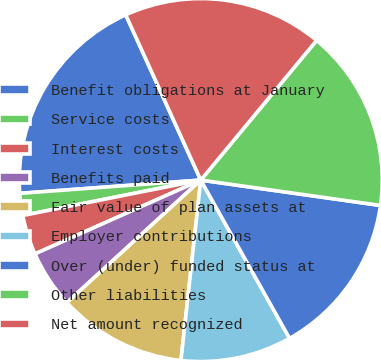<chart> <loc_0><loc_0><loc_500><loc_500><pie_chart><fcel>Benefit obligations at January<fcel>Service costs<fcel>Interest costs<fcel>Benefits paid<fcel>Fair value of plan assets at<fcel>Employer contributions<fcel>Over (under) funded status at<fcel>Other liabilities<fcel>Net amount recognized<nl><fcel>19.38%<fcel>1.96%<fcel>3.54%<fcel>5.13%<fcel>11.46%<fcel>9.88%<fcel>14.63%<fcel>16.21%<fcel>17.8%<nl></chart> 